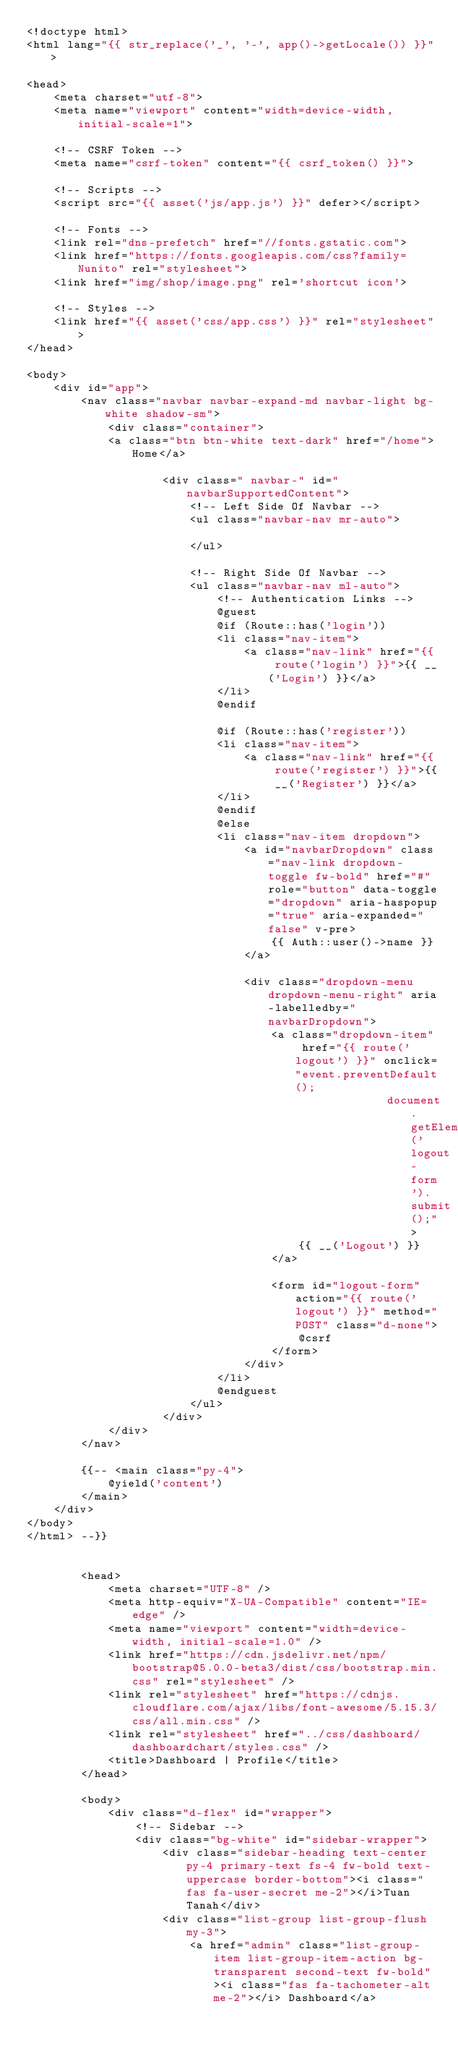<code> <loc_0><loc_0><loc_500><loc_500><_PHP_><!doctype html>
<html lang="{{ str_replace('_', '-', app()->getLocale()) }}">

<head>
    <meta charset="utf-8">
    <meta name="viewport" content="width=device-width, initial-scale=1">

    <!-- CSRF Token -->
    <meta name="csrf-token" content="{{ csrf_token() }}">

    <!-- Scripts -->
    <script src="{{ asset('js/app.js') }}" defer></script>

    <!-- Fonts -->
    <link rel="dns-prefetch" href="//fonts.gstatic.com">
    <link href="https://fonts.googleapis.com/css?family=Nunito" rel="stylesheet">
    <link href="img/shop/image.png" rel='shortcut icon'>

    <!-- Styles -->
    <link href="{{ asset('css/app.css') }}" rel="stylesheet">
</head>

<body>
    <div id="app">
        <nav class="navbar navbar-expand-md navbar-light bg-white shadow-sm">
            <div class="container">
            <a class="btn btn-white text-dark" href="/home">Home</a>

                    <div class=" navbar-" id="navbarSupportedContent">
                        <!-- Left Side Of Navbar -->
                        <ul class="navbar-nav mr-auto">

                        </ul>

                        <!-- Right Side Of Navbar -->
                        <ul class="navbar-nav ml-auto">
                            <!-- Authentication Links -->
                            @guest
                            @if (Route::has('login'))
                            <li class="nav-item">
                                <a class="nav-link" href="{{ route('login') }}">{{ __('Login') }}</a>
                            </li>
                            @endif

                            @if (Route::has('register'))
                            <li class="nav-item">
                                <a class="nav-link" href="{{ route('register') }}">{{ __('Register') }}</a>
                            </li>
                            @endif
                            @else
                            <li class="nav-item dropdown">
                                <a id="navbarDropdown" class="nav-link dropdown-toggle fw-bold" href="#" role="button" data-toggle="dropdown" aria-haspopup="true" aria-expanded="false" v-pre>
                                    {{ Auth::user()->name }}
                                </a>

                                <div class="dropdown-menu dropdown-menu-right" aria-labelledby="navbarDropdown">
                                    <a class="dropdown-item" href="{{ route('logout') }}" onclick="event.preventDefault();
                                                     document.getElementById('logout-form').submit();">
                                        {{ __('Logout') }}
                                    </a>

                                    <form id="logout-form" action="{{ route('logout') }}" method="POST" class="d-none">
                                        @csrf
                                    </form>
                                </div>
                            </li>
                            @endguest
                        </ul>
                    </div>
            </div>
        </nav>

        {{-- <main class="py-4">
            @yield('content')
        </main>
    </div>
</body>
</html> --}}


        <head>
            <meta charset="UTF-8" />
            <meta http-equiv="X-UA-Compatible" content="IE=edge" />
            <meta name="viewport" content="width=device-width, initial-scale=1.0" />
            <link href="https://cdn.jsdelivr.net/npm/bootstrap@5.0.0-beta3/dist/css/bootstrap.min.css" rel="stylesheet" />
            <link rel="stylesheet" href="https://cdnjs.cloudflare.com/ajax/libs/font-awesome/5.15.3/css/all.min.css" />
            <link rel="stylesheet" href="../css/dashboard/dashboardchart/styles.css" />
            <title>Dashboard | Profile</title>
        </head>

        <body>
            <div class="d-flex" id="wrapper">
                <!-- Sidebar -->
                <div class="bg-white" id="sidebar-wrapper">
                    <div class="sidebar-heading text-center py-4 primary-text fs-4 fw-bold text-uppercase border-bottom"><i class="fas fa-user-secret me-2"></i>Tuan Tanah</div>
                    <div class="list-group list-group-flush my-3">
                        <a href="admin" class="list-group-item list-group-item-action bg-transparent second-text fw-bold"><i class="fas fa-tachometer-alt me-2"></i> Dashboard</a></code> 